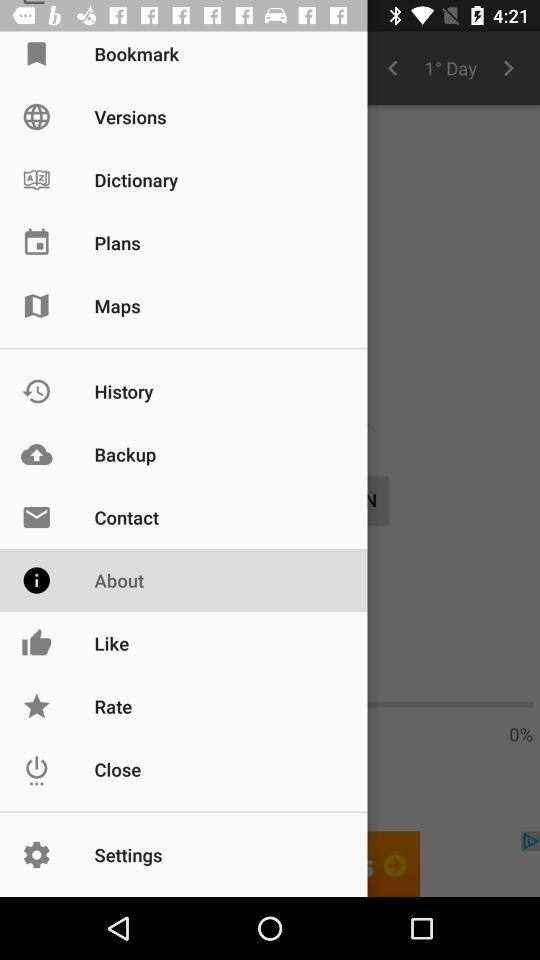What option is selected? The selected option is "About". 